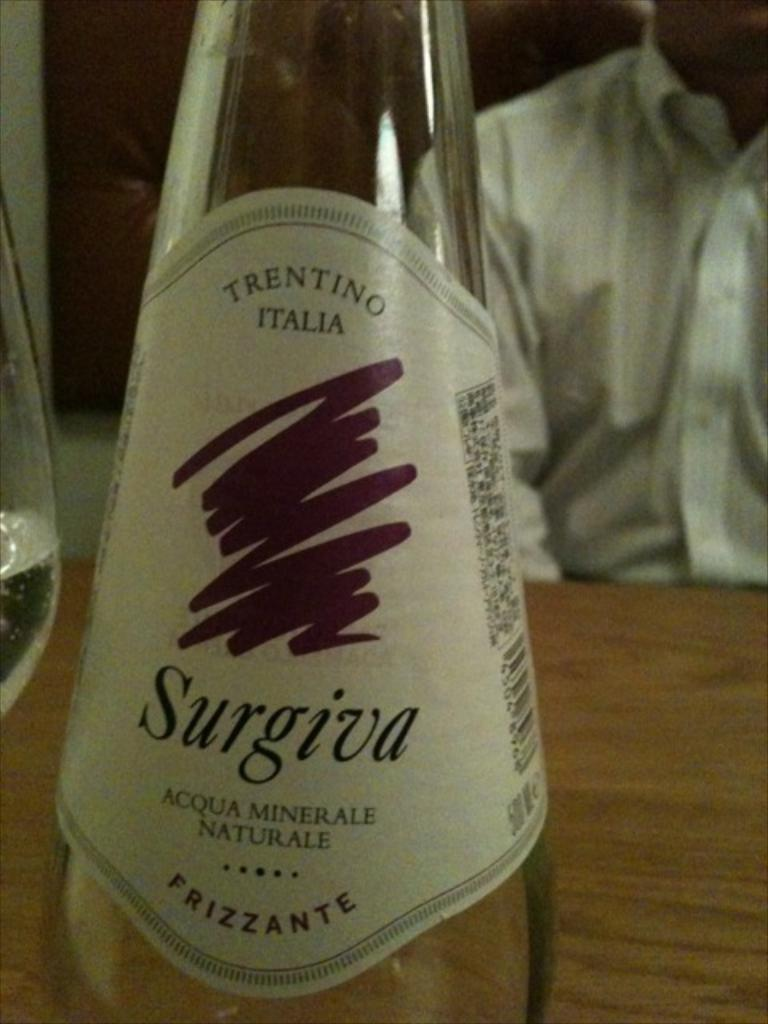What objects are on the table in the image? There are bottles on a table in the image. Can you describe the person in the image? A person wearing a white shirt is partially visible in the image. What type of patch is being distributed by the person in the image? There is no patch or distribution activity present in the image; it only shows bottles on a table and a person wearing a white shirt. 